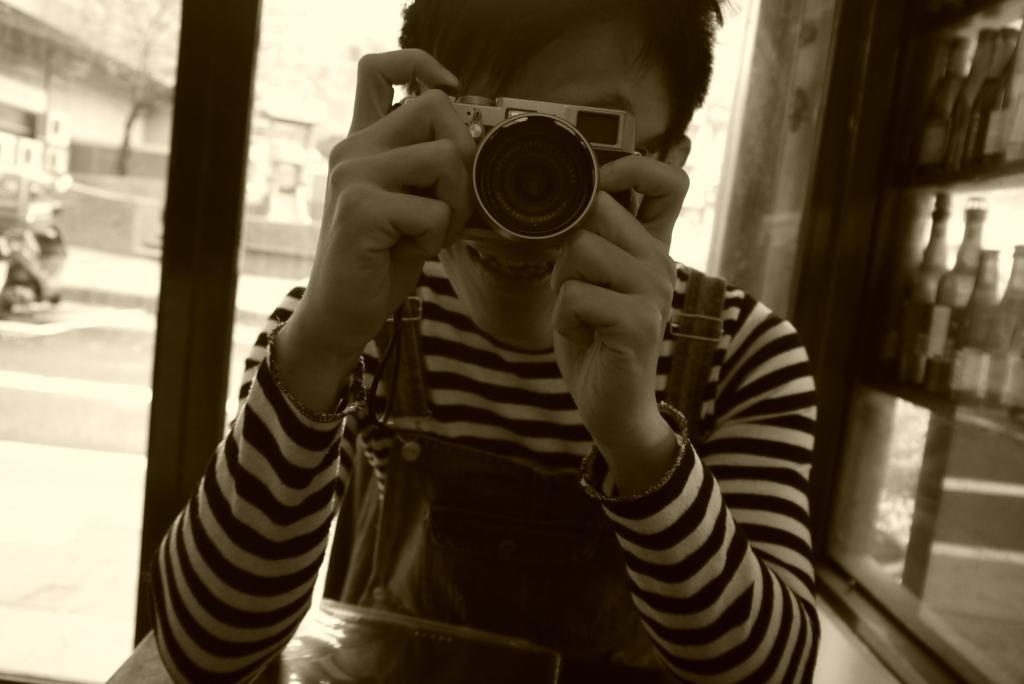Could you give a brief overview of what you see in this image? This is black and white picture. Here we can see a man who is holding a camera with his hands. And there is a pole. Here we can see some bottles. 